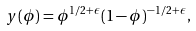<formula> <loc_0><loc_0><loc_500><loc_500>y ( \phi ) = \phi ^ { 1 / 2 + \epsilon } ( 1 - \phi ) ^ { - 1 / 2 + \epsilon } \, ,</formula> 